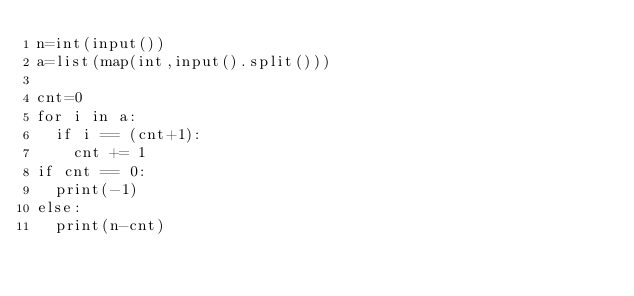Convert code to text. <code><loc_0><loc_0><loc_500><loc_500><_Python_>n=int(input())
a=list(map(int,input().split()))

cnt=0
for i in a:
  if i == (cnt+1):
    cnt += 1
if cnt == 0:
  print(-1)
else:
  print(n-cnt)</code> 